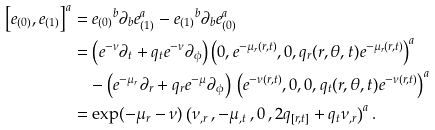<formula> <loc_0><loc_0><loc_500><loc_500>\left [ e _ { ( 0 ) } , e _ { ( 1 ) } \right ] ^ { a } & = { e _ { ( 0 ) } } ^ { b } \partial _ { b } e _ { ( 1 ) } ^ { a } - { e _ { ( 1 ) } } ^ { b } \partial _ { b } e _ { ( 0 ) } ^ { a } \\ & = \left ( e ^ { - \nu } \partial _ { t } + q _ { t } e ^ { - \nu } \partial _ { \phi } \right ) \left ( 0 , e ^ { - \mu _ { r } ( r , t ) } , 0 , q _ { r } ( r , \theta , t ) e ^ { - \mu _ { r } ( r , t ) } \right ) ^ { a } \\ & \quad - \left ( e ^ { - \mu _ { r } } \partial _ { r } + q _ { r } e ^ { - \mu } \partial _ { \phi } \right ) \, \left ( e ^ { - \nu ( r , t ) } , 0 , 0 , q _ { t } ( r , \theta , t ) e ^ { - \nu ( r , t ) } \right ) ^ { a } \\ & = \exp ( - \mu _ { r } - \nu ) \left ( \nu _ { , r } \, , - \mu _ { , t } \, , 0 \, , 2 q _ { [ r , t ] } + q _ { t } \nu _ { , r } \right ) ^ { a } .</formula> 